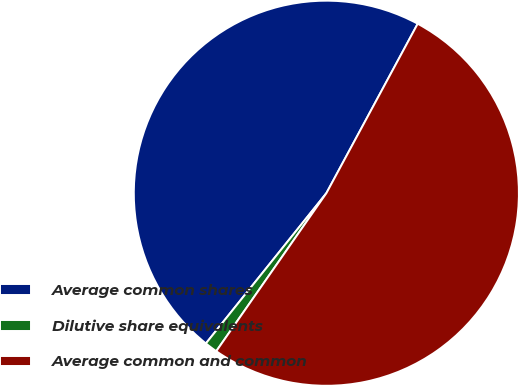Convert chart. <chart><loc_0><loc_0><loc_500><loc_500><pie_chart><fcel>Average common shares<fcel>Dilutive share equivalents<fcel>Average common and common<nl><fcel>47.11%<fcel>1.07%<fcel>51.82%<nl></chart> 